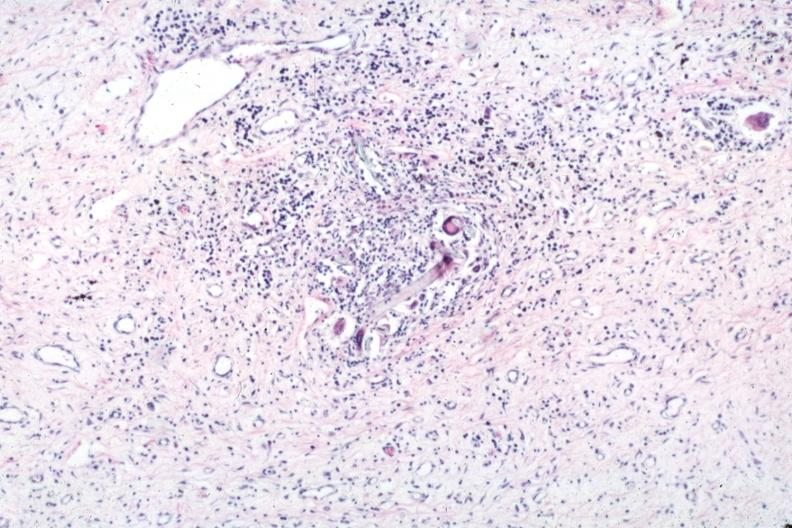what does this image show?
Answer the question using a single word or phrase. Typical lesion with giant cells and foreign material 